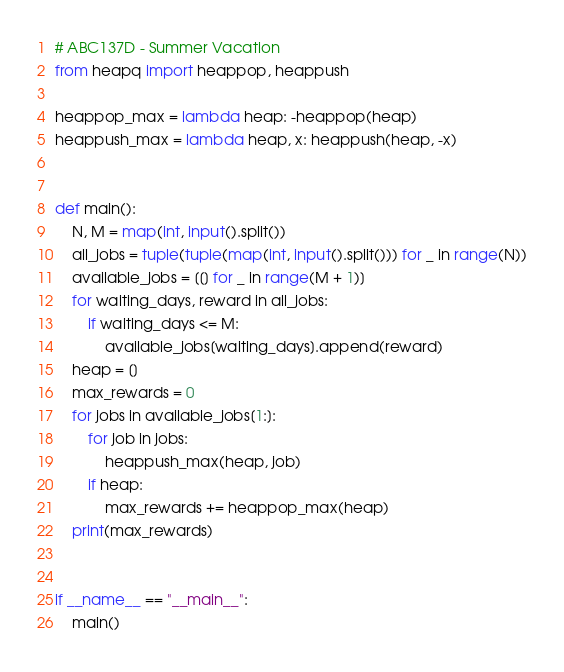<code> <loc_0><loc_0><loc_500><loc_500><_Python_># ABC137D - Summer Vacation
from heapq import heappop, heappush

heappop_max = lambda heap: -heappop(heap)
heappush_max = lambda heap, x: heappush(heap, -x)


def main():
    N, M = map(int, input().split())
    all_jobs = tuple(tuple(map(int, input().split())) for _ in range(N))
    available_jobs = [[] for _ in range(M + 1)]
    for waiting_days, reward in all_jobs:
        if waiting_days <= M:
            available_jobs[waiting_days].append(reward)
    heap = []
    max_rewards = 0
    for jobs in available_jobs[1:]:
        for job in jobs:
            heappush_max(heap, job)
        if heap:
            max_rewards += heappop_max(heap)
    print(max_rewards)


if __name__ == "__main__":
    main()
</code> 